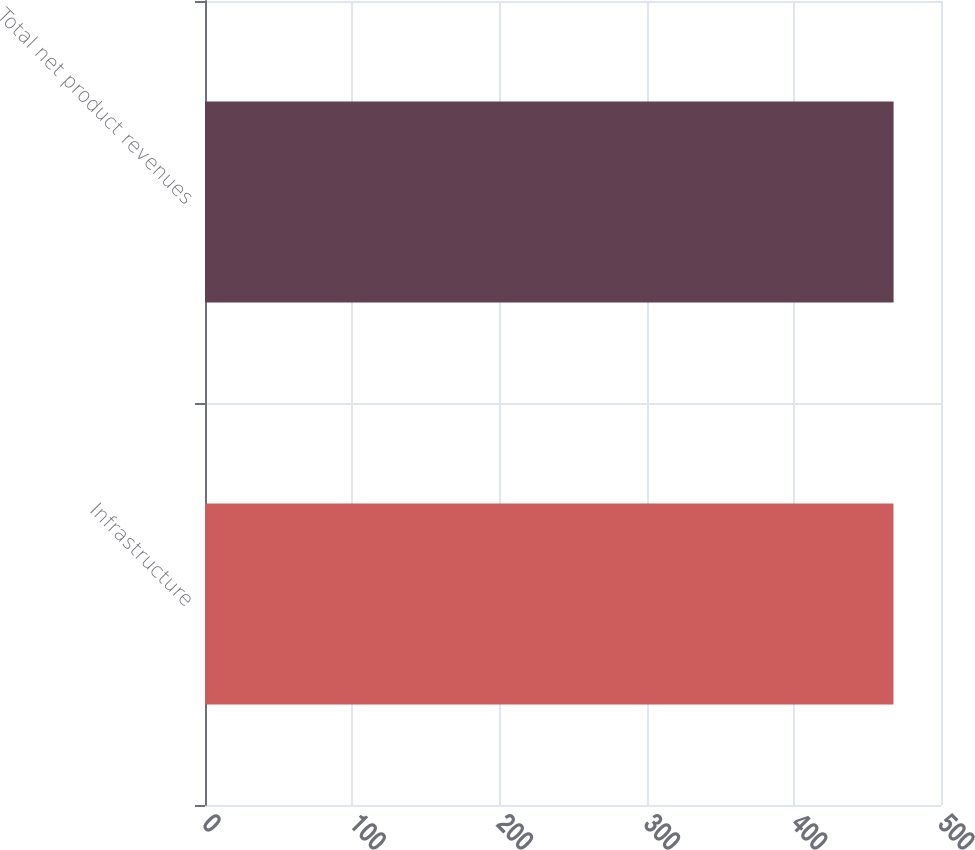Convert chart to OTSL. <chart><loc_0><loc_0><loc_500><loc_500><bar_chart><fcel>Infrastructure<fcel>Total net product revenues<nl><fcel>467.7<fcel>467.8<nl></chart> 